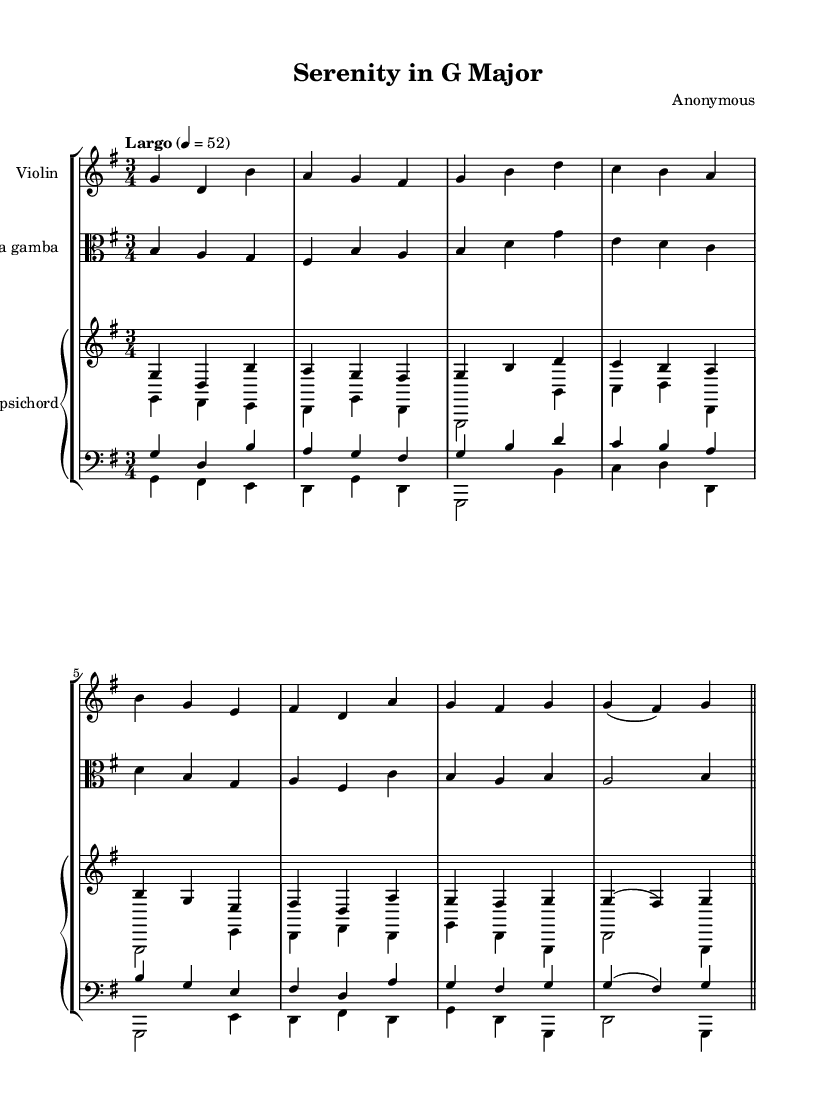What is the key signature of this music? The key signature is G major, which has one sharp (F#). This can be determined by looking at the key signature indicated at the beginning of the score, right after the clef.
Answer: G major What is the time signature of this music? The time signature is 3/4, indicated at the beginning of the score next to the key signature. This shows that there are three beats in each measure, and a quarter note receives one beat.
Answer: 3/4 What is the tempo marking of this piece? The tempo marking is Largo, with a metronome mark of 52. This can be found near the beginning of the score and indicates a slow tempo.
Answer: Largo How many measures are present in the piece? The piece consists of eight measures. This can be counted by identifying the bar lines in the score, which separate the measures.
Answer: Eight Which instruments are featured in this chamber music? The instruments featured are violin, viola da gamba, and harpsichord. This information is located at the beginning of each staff in the score, listing the specific instrument names.
Answer: Violin, viola da gamba, harpsichord What is the texture type of this Baroque composition? The texture type is generally polyphonic, as it often features multiple independent melodic lines. This can be assessed by examining the different melodic lines in the different staves, which interact with each other.
Answer: Polyphonic What is the predominant characteristic of the harmony in the piece? The predominant characteristic is functional harmony, as the piece uses chord progressions typical of the Baroque style to create tension and resolution. This can be inferred from the chord structures indicated in the harpsichord part and their relation to the melodic lines.
Answer: Functional harmony 